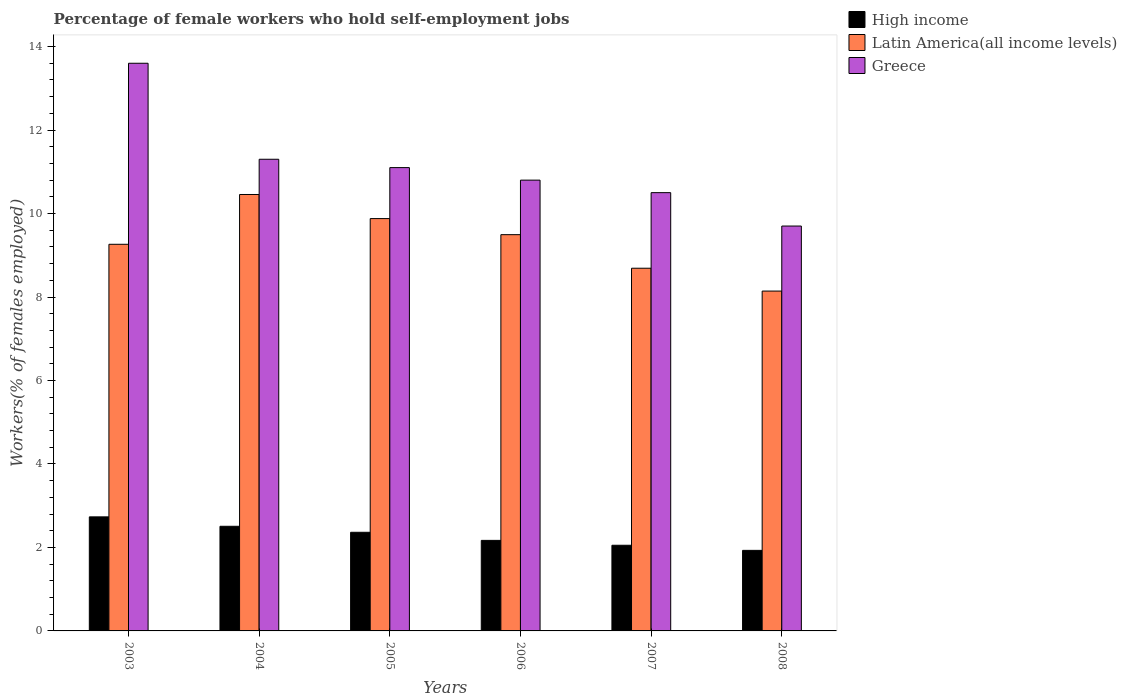How many different coloured bars are there?
Offer a terse response. 3. How many groups of bars are there?
Give a very brief answer. 6. Are the number of bars on each tick of the X-axis equal?
Offer a terse response. Yes. How many bars are there on the 1st tick from the left?
Keep it short and to the point. 3. How many bars are there on the 4th tick from the right?
Your response must be concise. 3. What is the percentage of self-employed female workers in Greece in 2008?
Ensure brevity in your answer.  9.7. Across all years, what is the maximum percentage of self-employed female workers in Greece?
Your answer should be very brief. 13.6. Across all years, what is the minimum percentage of self-employed female workers in Latin America(all income levels)?
Your response must be concise. 8.14. In which year was the percentage of self-employed female workers in Greece maximum?
Offer a very short reply. 2003. What is the total percentage of self-employed female workers in Latin America(all income levels) in the graph?
Ensure brevity in your answer.  55.92. What is the difference between the percentage of self-employed female workers in Greece in 2004 and that in 2008?
Make the answer very short. 1.6. What is the difference between the percentage of self-employed female workers in Greece in 2007 and the percentage of self-employed female workers in High income in 2005?
Your answer should be compact. 8.14. What is the average percentage of self-employed female workers in Greece per year?
Offer a terse response. 11.17. In the year 2004, what is the difference between the percentage of self-employed female workers in Latin America(all income levels) and percentage of self-employed female workers in High income?
Offer a terse response. 7.95. In how many years, is the percentage of self-employed female workers in Greece greater than 7.2 %?
Your answer should be very brief. 6. What is the ratio of the percentage of self-employed female workers in High income in 2004 to that in 2006?
Your answer should be compact. 1.16. Is the difference between the percentage of self-employed female workers in Latin America(all income levels) in 2003 and 2006 greater than the difference between the percentage of self-employed female workers in High income in 2003 and 2006?
Offer a very short reply. No. What is the difference between the highest and the second highest percentage of self-employed female workers in Latin America(all income levels)?
Make the answer very short. 0.58. What is the difference between the highest and the lowest percentage of self-employed female workers in Greece?
Provide a short and direct response. 3.9. Is the sum of the percentage of self-employed female workers in High income in 2003 and 2008 greater than the maximum percentage of self-employed female workers in Latin America(all income levels) across all years?
Offer a very short reply. No. What does the 2nd bar from the left in 2007 represents?
Your answer should be very brief. Latin America(all income levels). What is the difference between two consecutive major ticks on the Y-axis?
Offer a very short reply. 2. Are the values on the major ticks of Y-axis written in scientific E-notation?
Your answer should be compact. No. Does the graph contain grids?
Give a very brief answer. No. Where does the legend appear in the graph?
Keep it short and to the point. Top right. How many legend labels are there?
Your answer should be very brief. 3. What is the title of the graph?
Keep it short and to the point. Percentage of female workers who hold self-employment jobs. Does "Madagascar" appear as one of the legend labels in the graph?
Offer a terse response. No. What is the label or title of the Y-axis?
Keep it short and to the point. Workers(% of females employed). What is the Workers(% of females employed) in High income in 2003?
Give a very brief answer. 2.73. What is the Workers(% of females employed) in Latin America(all income levels) in 2003?
Keep it short and to the point. 9.26. What is the Workers(% of females employed) in Greece in 2003?
Give a very brief answer. 13.6. What is the Workers(% of females employed) in High income in 2004?
Provide a short and direct response. 2.51. What is the Workers(% of females employed) in Latin America(all income levels) in 2004?
Your answer should be compact. 10.46. What is the Workers(% of females employed) of Greece in 2004?
Keep it short and to the point. 11.3. What is the Workers(% of females employed) in High income in 2005?
Offer a terse response. 2.36. What is the Workers(% of females employed) in Latin America(all income levels) in 2005?
Ensure brevity in your answer.  9.88. What is the Workers(% of females employed) of Greece in 2005?
Your response must be concise. 11.1. What is the Workers(% of females employed) of High income in 2006?
Ensure brevity in your answer.  2.17. What is the Workers(% of females employed) of Latin America(all income levels) in 2006?
Your answer should be compact. 9.49. What is the Workers(% of females employed) of Greece in 2006?
Provide a short and direct response. 10.8. What is the Workers(% of females employed) of High income in 2007?
Ensure brevity in your answer.  2.05. What is the Workers(% of females employed) in Latin America(all income levels) in 2007?
Your answer should be compact. 8.69. What is the Workers(% of females employed) in Greece in 2007?
Provide a short and direct response. 10.5. What is the Workers(% of females employed) in High income in 2008?
Offer a very short reply. 1.93. What is the Workers(% of females employed) in Latin America(all income levels) in 2008?
Provide a short and direct response. 8.14. What is the Workers(% of females employed) of Greece in 2008?
Ensure brevity in your answer.  9.7. Across all years, what is the maximum Workers(% of females employed) of High income?
Provide a short and direct response. 2.73. Across all years, what is the maximum Workers(% of females employed) of Latin America(all income levels)?
Make the answer very short. 10.46. Across all years, what is the maximum Workers(% of females employed) of Greece?
Offer a terse response. 13.6. Across all years, what is the minimum Workers(% of females employed) of High income?
Give a very brief answer. 1.93. Across all years, what is the minimum Workers(% of females employed) of Latin America(all income levels)?
Ensure brevity in your answer.  8.14. Across all years, what is the minimum Workers(% of females employed) of Greece?
Make the answer very short. 9.7. What is the total Workers(% of females employed) of High income in the graph?
Give a very brief answer. 13.75. What is the total Workers(% of females employed) in Latin America(all income levels) in the graph?
Ensure brevity in your answer.  55.92. What is the difference between the Workers(% of females employed) in High income in 2003 and that in 2004?
Your answer should be very brief. 0.23. What is the difference between the Workers(% of females employed) in Latin America(all income levels) in 2003 and that in 2004?
Your answer should be compact. -1.19. What is the difference between the Workers(% of females employed) in High income in 2003 and that in 2005?
Ensure brevity in your answer.  0.37. What is the difference between the Workers(% of females employed) of Latin America(all income levels) in 2003 and that in 2005?
Provide a succinct answer. -0.62. What is the difference between the Workers(% of females employed) in Greece in 2003 and that in 2005?
Keep it short and to the point. 2.5. What is the difference between the Workers(% of females employed) of High income in 2003 and that in 2006?
Your answer should be compact. 0.56. What is the difference between the Workers(% of females employed) of Latin America(all income levels) in 2003 and that in 2006?
Make the answer very short. -0.23. What is the difference between the Workers(% of females employed) of Greece in 2003 and that in 2006?
Offer a very short reply. 2.8. What is the difference between the Workers(% of females employed) in High income in 2003 and that in 2007?
Make the answer very short. 0.68. What is the difference between the Workers(% of females employed) in Latin America(all income levels) in 2003 and that in 2007?
Give a very brief answer. 0.57. What is the difference between the Workers(% of females employed) of High income in 2003 and that in 2008?
Make the answer very short. 0.8. What is the difference between the Workers(% of females employed) in Latin America(all income levels) in 2003 and that in 2008?
Offer a terse response. 1.12. What is the difference between the Workers(% of females employed) in Greece in 2003 and that in 2008?
Give a very brief answer. 3.9. What is the difference between the Workers(% of females employed) in High income in 2004 and that in 2005?
Your response must be concise. 0.14. What is the difference between the Workers(% of females employed) in Latin America(all income levels) in 2004 and that in 2005?
Offer a very short reply. 0.58. What is the difference between the Workers(% of females employed) in High income in 2004 and that in 2006?
Ensure brevity in your answer.  0.34. What is the difference between the Workers(% of females employed) of Latin America(all income levels) in 2004 and that in 2006?
Your answer should be very brief. 0.96. What is the difference between the Workers(% of females employed) of Greece in 2004 and that in 2006?
Give a very brief answer. 0.5. What is the difference between the Workers(% of females employed) in High income in 2004 and that in 2007?
Provide a succinct answer. 0.45. What is the difference between the Workers(% of females employed) of Latin America(all income levels) in 2004 and that in 2007?
Your response must be concise. 1.77. What is the difference between the Workers(% of females employed) in High income in 2004 and that in 2008?
Offer a terse response. 0.58. What is the difference between the Workers(% of females employed) of Latin America(all income levels) in 2004 and that in 2008?
Give a very brief answer. 2.31. What is the difference between the Workers(% of females employed) in High income in 2005 and that in 2006?
Your answer should be very brief. 0.19. What is the difference between the Workers(% of females employed) of Latin America(all income levels) in 2005 and that in 2006?
Make the answer very short. 0.39. What is the difference between the Workers(% of females employed) in High income in 2005 and that in 2007?
Offer a terse response. 0.31. What is the difference between the Workers(% of females employed) of Latin America(all income levels) in 2005 and that in 2007?
Keep it short and to the point. 1.19. What is the difference between the Workers(% of females employed) of Greece in 2005 and that in 2007?
Provide a succinct answer. 0.6. What is the difference between the Workers(% of females employed) of High income in 2005 and that in 2008?
Your answer should be very brief. 0.43. What is the difference between the Workers(% of females employed) of Latin America(all income levels) in 2005 and that in 2008?
Offer a terse response. 1.74. What is the difference between the Workers(% of females employed) in Greece in 2005 and that in 2008?
Give a very brief answer. 1.4. What is the difference between the Workers(% of females employed) of High income in 2006 and that in 2007?
Your answer should be very brief. 0.12. What is the difference between the Workers(% of females employed) in Latin America(all income levels) in 2006 and that in 2007?
Offer a terse response. 0.8. What is the difference between the Workers(% of females employed) in High income in 2006 and that in 2008?
Ensure brevity in your answer.  0.24. What is the difference between the Workers(% of females employed) of Latin America(all income levels) in 2006 and that in 2008?
Provide a short and direct response. 1.35. What is the difference between the Workers(% of females employed) in Greece in 2006 and that in 2008?
Give a very brief answer. 1.1. What is the difference between the Workers(% of females employed) in High income in 2007 and that in 2008?
Provide a short and direct response. 0.12. What is the difference between the Workers(% of females employed) in Latin America(all income levels) in 2007 and that in 2008?
Ensure brevity in your answer.  0.55. What is the difference between the Workers(% of females employed) of Greece in 2007 and that in 2008?
Your response must be concise. 0.8. What is the difference between the Workers(% of females employed) of High income in 2003 and the Workers(% of females employed) of Latin America(all income levels) in 2004?
Make the answer very short. -7.72. What is the difference between the Workers(% of females employed) in High income in 2003 and the Workers(% of females employed) in Greece in 2004?
Offer a very short reply. -8.57. What is the difference between the Workers(% of females employed) in Latin America(all income levels) in 2003 and the Workers(% of females employed) in Greece in 2004?
Keep it short and to the point. -2.04. What is the difference between the Workers(% of females employed) of High income in 2003 and the Workers(% of females employed) of Latin America(all income levels) in 2005?
Provide a short and direct response. -7.15. What is the difference between the Workers(% of females employed) in High income in 2003 and the Workers(% of females employed) in Greece in 2005?
Make the answer very short. -8.37. What is the difference between the Workers(% of females employed) in Latin America(all income levels) in 2003 and the Workers(% of females employed) in Greece in 2005?
Give a very brief answer. -1.84. What is the difference between the Workers(% of females employed) in High income in 2003 and the Workers(% of females employed) in Latin America(all income levels) in 2006?
Offer a very short reply. -6.76. What is the difference between the Workers(% of females employed) in High income in 2003 and the Workers(% of females employed) in Greece in 2006?
Ensure brevity in your answer.  -8.07. What is the difference between the Workers(% of females employed) of Latin America(all income levels) in 2003 and the Workers(% of females employed) of Greece in 2006?
Keep it short and to the point. -1.54. What is the difference between the Workers(% of females employed) of High income in 2003 and the Workers(% of females employed) of Latin America(all income levels) in 2007?
Offer a terse response. -5.96. What is the difference between the Workers(% of females employed) in High income in 2003 and the Workers(% of females employed) in Greece in 2007?
Offer a terse response. -7.77. What is the difference between the Workers(% of females employed) in Latin America(all income levels) in 2003 and the Workers(% of females employed) in Greece in 2007?
Offer a terse response. -1.24. What is the difference between the Workers(% of females employed) in High income in 2003 and the Workers(% of females employed) in Latin America(all income levels) in 2008?
Give a very brief answer. -5.41. What is the difference between the Workers(% of females employed) in High income in 2003 and the Workers(% of females employed) in Greece in 2008?
Make the answer very short. -6.97. What is the difference between the Workers(% of females employed) of Latin America(all income levels) in 2003 and the Workers(% of females employed) of Greece in 2008?
Provide a short and direct response. -0.44. What is the difference between the Workers(% of females employed) of High income in 2004 and the Workers(% of females employed) of Latin America(all income levels) in 2005?
Your answer should be very brief. -7.37. What is the difference between the Workers(% of females employed) in High income in 2004 and the Workers(% of females employed) in Greece in 2005?
Provide a short and direct response. -8.59. What is the difference between the Workers(% of females employed) of Latin America(all income levels) in 2004 and the Workers(% of females employed) of Greece in 2005?
Your answer should be very brief. -0.64. What is the difference between the Workers(% of females employed) of High income in 2004 and the Workers(% of females employed) of Latin America(all income levels) in 2006?
Provide a short and direct response. -6.99. What is the difference between the Workers(% of females employed) of High income in 2004 and the Workers(% of females employed) of Greece in 2006?
Your answer should be compact. -8.29. What is the difference between the Workers(% of females employed) in Latin America(all income levels) in 2004 and the Workers(% of females employed) in Greece in 2006?
Give a very brief answer. -0.34. What is the difference between the Workers(% of females employed) in High income in 2004 and the Workers(% of females employed) in Latin America(all income levels) in 2007?
Offer a very short reply. -6.18. What is the difference between the Workers(% of females employed) of High income in 2004 and the Workers(% of females employed) of Greece in 2007?
Your response must be concise. -7.99. What is the difference between the Workers(% of females employed) of Latin America(all income levels) in 2004 and the Workers(% of females employed) of Greece in 2007?
Offer a terse response. -0.04. What is the difference between the Workers(% of females employed) of High income in 2004 and the Workers(% of females employed) of Latin America(all income levels) in 2008?
Your answer should be very brief. -5.64. What is the difference between the Workers(% of females employed) in High income in 2004 and the Workers(% of females employed) in Greece in 2008?
Your response must be concise. -7.19. What is the difference between the Workers(% of females employed) in Latin America(all income levels) in 2004 and the Workers(% of females employed) in Greece in 2008?
Your answer should be compact. 0.76. What is the difference between the Workers(% of females employed) of High income in 2005 and the Workers(% of females employed) of Latin America(all income levels) in 2006?
Give a very brief answer. -7.13. What is the difference between the Workers(% of females employed) of High income in 2005 and the Workers(% of females employed) of Greece in 2006?
Offer a terse response. -8.44. What is the difference between the Workers(% of females employed) in Latin America(all income levels) in 2005 and the Workers(% of females employed) in Greece in 2006?
Offer a very short reply. -0.92. What is the difference between the Workers(% of females employed) of High income in 2005 and the Workers(% of females employed) of Latin America(all income levels) in 2007?
Offer a very short reply. -6.33. What is the difference between the Workers(% of females employed) in High income in 2005 and the Workers(% of females employed) in Greece in 2007?
Offer a very short reply. -8.14. What is the difference between the Workers(% of females employed) of Latin America(all income levels) in 2005 and the Workers(% of females employed) of Greece in 2007?
Make the answer very short. -0.62. What is the difference between the Workers(% of females employed) in High income in 2005 and the Workers(% of females employed) in Latin America(all income levels) in 2008?
Your answer should be compact. -5.78. What is the difference between the Workers(% of females employed) in High income in 2005 and the Workers(% of females employed) in Greece in 2008?
Offer a terse response. -7.34. What is the difference between the Workers(% of females employed) of Latin America(all income levels) in 2005 and the Workers(% of females employed) of Greece in 2008?
Provide a succinct answer. 0.18. What is the difference between the Workers(% of females employed) in High income in 2006 and the Workers(% of females employed) in Latin America(all income levels) in 2007?
Make the answer very short. -6.52. What is the difference between the Workers(% of females employed) of High income in 2006 and the Workers(% of females employed) of Greece in 2007?
Make the answer very short. -8.33. What is the difference between the Workers(% of females employed) in Latin America(all income levels) in 2006 and the Workers(% of females employed) in Greece in 2007?
Provide a succinct answer. -1.01. What is the difference between the Workers(% of females employed) in High income in 2006 and the Workers(% of females employed) in Latin America(all income levels) in 2008?
Offer a very short reply. -5.97. What is the difference between the Workers(% of females employed) of High income in 2006 and the Workers(% of females employed) of Greece in 2008?
Provide a short and direct response. -7.53. What is the difference between the Workers(% of females employed) in Latin America(all income levels) in 2006 and the Workers(% of females employed) in Greece in 2008?
Provide a succinct answer. -0.21. What is the difference between the Workers(% of females employed) of High income in 2007 and the Workers(% of females employed) of Latin America(all income levels) in 2008?
Ensure brevity in your answer.  -6.09. What is the difference between the Workers(% of females employed) in High income in 2007 and the Workers(% of females employed) in Greece in 2008?
Offer a terse response. -7.65. What is the difference between the Workers(% of females employed) in Latin America(all income levels) in 2007 and the Workers(% of females employed) in Greece in 2008?
Keep it short and to the point. -1.01. What is the average Workers(% of females employed) in High income per year?
Offer a terse response. 2.29. What is the average Workers(% of females employed) in Latin America(all income levels) per year?
Your answer should be compact. 9.32. What is the average Workers(% of females employed) of Greece per year?
Give a very brief answer. 11.17. In the year 2003, what is the difference between the Workers(% of females employed) of High income and Workers(% of females employed) of Latin America(all income levels)?
Ensure brevity in your answer.  -6.53. In the year 2003, what is the difference between the Workers(% of females employed) in High income and Workers(% of females employed) in Greece?
Your answer should be very brief. -10.87. In the year 2003, what is the difference between the Workers(% of females employed) of Latin America(all income levels) and Workers(% of females employed) of Greece?
Keep it short and to the point. -4.34. In the year 2004, what is the difference between the Workers(% of females employed) in High income and Workers(% of females employed) in Latin America(all income levels)?
Your response must be concise. -7.95. In the year 2004, what is the difference between the Workers(% of females employed) of High income and Workers(% of females employed) of Greece?
Give a very brief answer. -8.79. In the year 2004, what is the difference between the Workers(% of females employed) of Latin America(all income levels) and Workers(% of females employed) of Greece?
Your response must be concise. -0.84. In the year 2005, what is the difference between the Workers(% of females employed) in High income and Workers(% of females employed) in Latin America(all income levels)?
Offer a terse response. -7.52. In the year 2005, what is the difference between the Workers(% of females employed) in High income and Workers(% of females employed) in Greece?
Offer a very short reply. -8.74. In the year 2005, what is the difference between the Workers(% of females employed) in Latin America(all income levels) and Workers(% of females employed) in Greece?
Your response must be concise. -1.22. In the year 2006, what is the difference between the Workers(% of females employed) of High income and Workers(% of females employed) of Latin America(all income levels)?
Keep it short and to the point. -7.32. In the year 2006, what is the difference between the Workers(% of females employed) of High income and Workers(% of females employed) of Greece?
Provide a short and direct response. -8.63. In the year 2006, what is the difference between the Workers(% of females employed) in Latin America(all income levels) and Workers(% of females employed) in Greece?
Provide a succinct answer. -1.31. In the year 2007, what is the difference between the Workers(% of females employed) in High income and Workers(% of females employed) in Latin America(all income levels)?
Provide a short and direct response. -6.64. In the year 2007, what is the difference between the Workers(% of females employed) of High income and Workers(% of females employed) of Greece?
Provide a succinct answer. -8.45. In the year 2007, what is the difference between the Workers(% of females employed) of Latin America(all income levels) and Workers(% of females employed) of Greece?
Keep it short and to the point. -1.81. In the year 2008, what is the difference between the Workers(% of females employed) of High income and Workers(% of females employed) of Latin America(all income levels)?
Offer a terse response. -6.21. In the year 2008, what is the difference between the Workers(% of females employed) in High income and Workers(% of females employed) in Greece?
Offer a very short reply. -7.77. In the year 2008, what is the difference between the Workers(% of females employed) in Latin America(all income levels) and Workers(% of females employed) in Greece?
Provide a succinct answer. -1.56. What is the ratio of the Workers(% of females employed) of High income in 2003 to that in 2004?
Provide a short and direct response. 1.09. What is the ratio of the Workers(% of females employed) of Latin America(all income levels) in 2003 to that in 2004?
Your answer should be very brief. 0.89. What is the ratio of the Workers(% of females employed) of Greece in 2003 to that in 2004?
Ensure brevity in your answer.  1.2. What is the ratio of the Workers(% of females employed) of High income in 2003 to that in 2005?
Keep it short and to the point. 1.16. What is the ratio of the Workers(% of females employed) in Latin America(all income levels) in 2003 to that in 2005?
Give a very brief answer. 0.94. What is the ratio of the Workers(% of females employed) of Greece in 2003 to that in 2005?
Offer a terse response. 1.23. What is the ratio of the Workers(% of females employed) of High income in 2003 to that in 2006?
Make the answer very short. 1.26. What is the ratio of the Workers(% of females employed) in Latin America(all income levels) in 2003 to that in 2006?
Give a very brief answer. 0.98. What is the ratio of the Workers(% of females employed) in Greece in 2003 to that in 2006?
Your answer should be compact. 1.26. What is the ratio of the Workers(% of females employed) of High income in 2003 to that in 2007?
Offer a very short reply. 1.33. What is the ratio of the Workers(% of females employed) of Latin America(all income levels) in 2003 to that in 2007?
Keep it short and to the point. 1.07. What is the ratio of the Workers(% of females employed) of Greece in 2003 to that in 2007?
Offer a terse response. 1.3. What is the ratio of the Workers(% of females employed) in High income in 2003 to that in 2008?
Your answer should be very brief. 1.42. What is the ratio of the Workers(% of females employed) of Latin America(all income levels) in 2003 to that in 2008?
Keep it short and to the point. 1.14. What is the ratio of the Workers(% of females employed) in Greece in 2003 to that in 2008?
Offer a terse response. 1.4. What is the ratio of the Workers(% of females employed) of High income in 2004 to that in 2005?
Provide a succinct answer. 1.06. What is the ratio of the Workers(% of females employed) of Latin America(all income levels) in 2004 to that in 2005?
Keep it short and to the point. 1.06. What is the ratio of the Workers(% of females employed) in Greece in 2004 to that in 2005?
Ensure brevity in your answer.  1.02. What is the ratio of the Workers(% of females employed) in High income in 2004 to that in 2006?
Provide a short and direct response. 1.16. What is the ratio of the Workers(% of females employed) in Latin America(all income levels) in 2004 to that in 2006?
Ensure brevity in your answer.  1.1. What is the ratio of the Workers(% of females employed) of Greece in 2004 to that in 2006?
Give a very brief answer. 1.05. What is the ratio of the Workers(% of females employed) in High income in 2004 to that in 2007?
Provide a succinct answer. 1.22. What is the ratio of the Workers(% of females employed) of Latin America(all income levels) in 2004 to that in 2007?
Offer a very short reply. 1.2. What is the ratio of the Workers(% of females employed) in Greece in 2004 to that in 2007?
Your response must be concise. 1.08. What is the ratio of the Workers(% of females employed) in High income in 2004 to that in 2008?
Give a very brief answer. 1.3. What is the ratio of the Workers(% of females employed) in Latin America(all income levels) in 2004 to that in 2008?
Make the answer very short. 1.28. What is the ratio of the Workers(% of females employed) in Greece in 2004 to that in 2008?
Keep it short and to the point. 1.16. What is the ratio of the Workers(% of females employed) in High income in 2005 to that in 2006?
Give a very brief answer. 1.09. What is the ratio of the Workers(% of females employed) in Latin America(all income levels) in 2005 to that in 2006?
Offer a very short reply. 1.04. What is the ratio of the Workers(% of females employed) of Greece in 2005 to that in 2006?
Provide a short and direct response. 1.03. What is the ratio of the Workers(% of females employed) of High income in 2005 to that in 2007?
Your answer should be very brief. 1.15. What is the ratio of the Workers(% of females employed) of Latin America(all income levels) in 2005 to that in 2007?
Offer a very short reply. 1.14. What is the ratio of the Workers(% of females employed) of Greece in 2005 to that in 2007?
Offer a very short reply. 1.06. What is the ratio of the Workers(% of females employed) in High income in 2005 to that in 2008?
Your answer should be very brief. 1.22. What is the ratio of the Workers(% of females employed) of Latin America(all income levels) in 2005 to that in 2008?
Your answer should be very brief. 1.21. What is the ratio of the Workers(% of females employed) in Greece in 2005 to that in 2008?
Offer a very short reply. 1.14. What is the ratio of the Workers(% of females employed) in High income in 2006 to that in 2007?
Your response must be concise. 1.06. What is the ratio of the Workers(% of females employed) of Latin America(all income levels) in 2006 to that in 2007?
Ensure brevity in your answer.  1.09. What is the ratio of the Workers(% of females employed) of Greece in 2006 to that in 2007?
Make the answer very short. 1.03. What is the ratio of the Workers(% of females employed) of High income in 2006 to that in 2008?
Offer a terse response. 1.12. What is the ratio of the Workers(% of females employed) of Latin America(all income levels) in 2006 to that in 2008?
Provide a succinct answer. 1.17. What is the ratio of the Workers(% of females employed) of Greece in 2006 to that in 2008?
Your answer should be compact. 1.11. What is the ratio of the Workers(% of females employed) of High income in 2007 to that in 2008?
Ensure brevity in your answer.  1.06. What is the ratio of the Workers(% of females employed) of Latin America(all income levels) in 2007 to that in 2008?
Provide a short and direct response. 1.07. What is the ratio of the Workers(% of females employed) of Greece in 2007 to that in 2008?
Give a very brief answer. 1.08. What is the difference between the highest and the second highest Workers(% of females employed) in High income?
Your answer should be compact. 0.23. What is the difference between the highest and the second highest Workers(% of females employed) of Latin America(all income levels)?
Offer a terse response. 0.58. What is the difference between the highest and the lowest Workers(% of females employed) of High income?
Offer a very short reply. 0.8. What is the difference between the highest and the lowest Workers(% of females employed) of Latin America(all income levels)?
Provide a succinct answer. 2.31. 